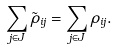<formula> <loc_0><loc_0><loc_500><loc_500>\sum _ { j \in J } \tilde { \rho } _ { i j } = \sum _ { j \in J } \rho _ { i j } .</formula> 